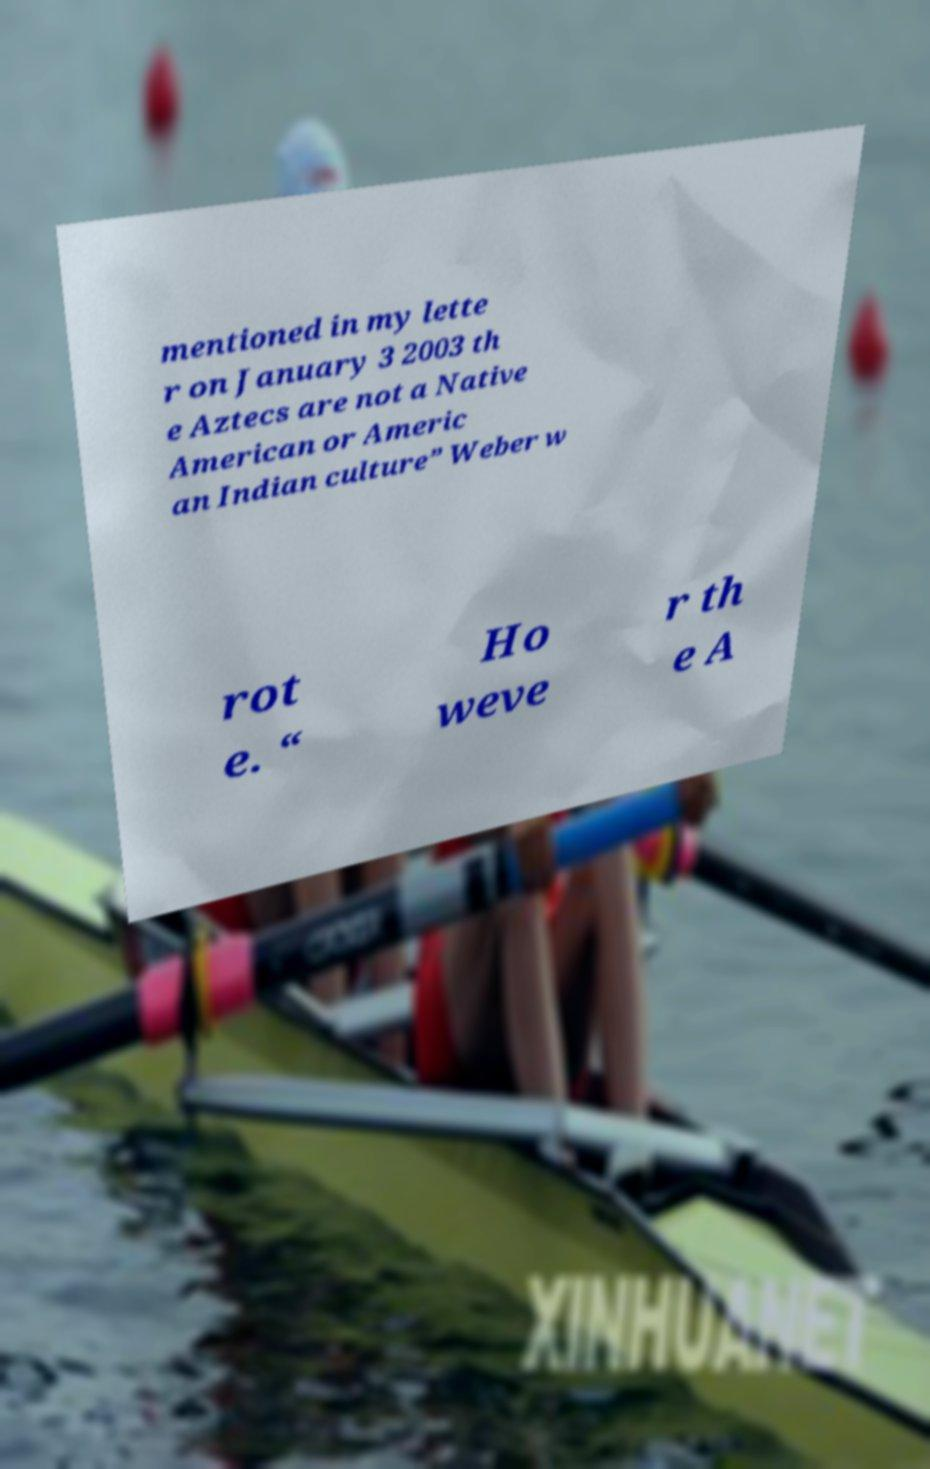Please identify and transcribe the text found in this image. mentioned in my lette r on January 3 2003 th e Aztecs are not a Native American or Americ an Indian culture” Weber w rot e. “ Ho weve r th e A 